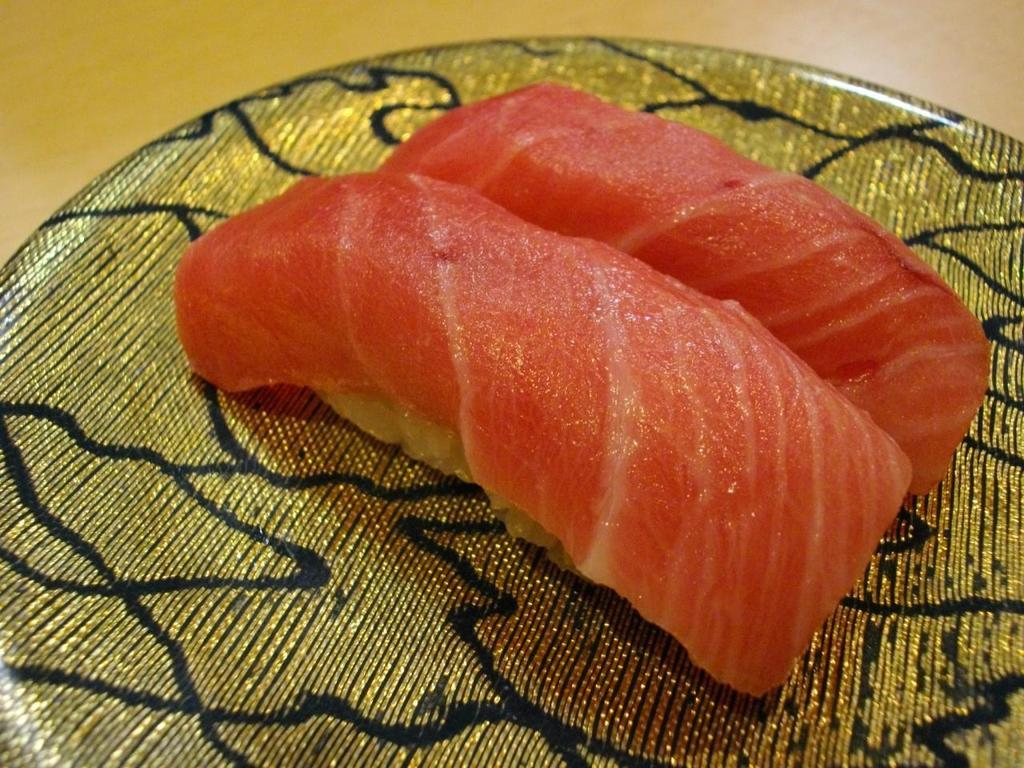What is the main subject of the image? The main subject of the image is flesh. How is the flesh presented in the image? The flesh is placed on a plate. What piece of furniture is visible in the image? There is a table in the image. How many sheep are visible in the image? There are no sheep present in the image. What type of snails can be seen crawling on the table in the image? There are no snails visible in the image. 